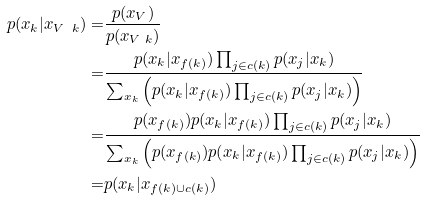Convert formula to latex. <formula><loc_0><loc_0><loc_500><loc_500>p ( x _ { k } | x _ { V \ k } ) = & \frac { p ( x _ { V } ) } { p ( x _ { V \ k } ) } \\ = & \frac { p ( x _ { k } | x _ { f ( k ) } ) \prod _ { j \in c ( k ) } p ( x _ { j } | x _ { k } ) } { \sum _ { x _ { k } } \left ( p ( x _ { k } | x _ { f ( k ) } ) \prod _ { j \in c ( k ) } p ( x _ { j } | x _ { k } ) \right ) } \\ = & \frac { p ( x _ { f ( k ) } ) p ( x _ { k } | x _ { f ( k ) } ) \prod _ { j \in c ( k ) } p ( x _ { j } | x _ { k } ) } { \sum _ { x _ { k } } \left ( p ( x _ { f ( k ) } ) p ( x _ { k } | x _ { f ( k ) } ) \prod _ { j \in c ( k ) } p ( x _ { j } | x _ { k } ) \right ) } \\ = & p ( x _ { k } | x _ { f ( k ) \cup c ( k ) } )</formula> 